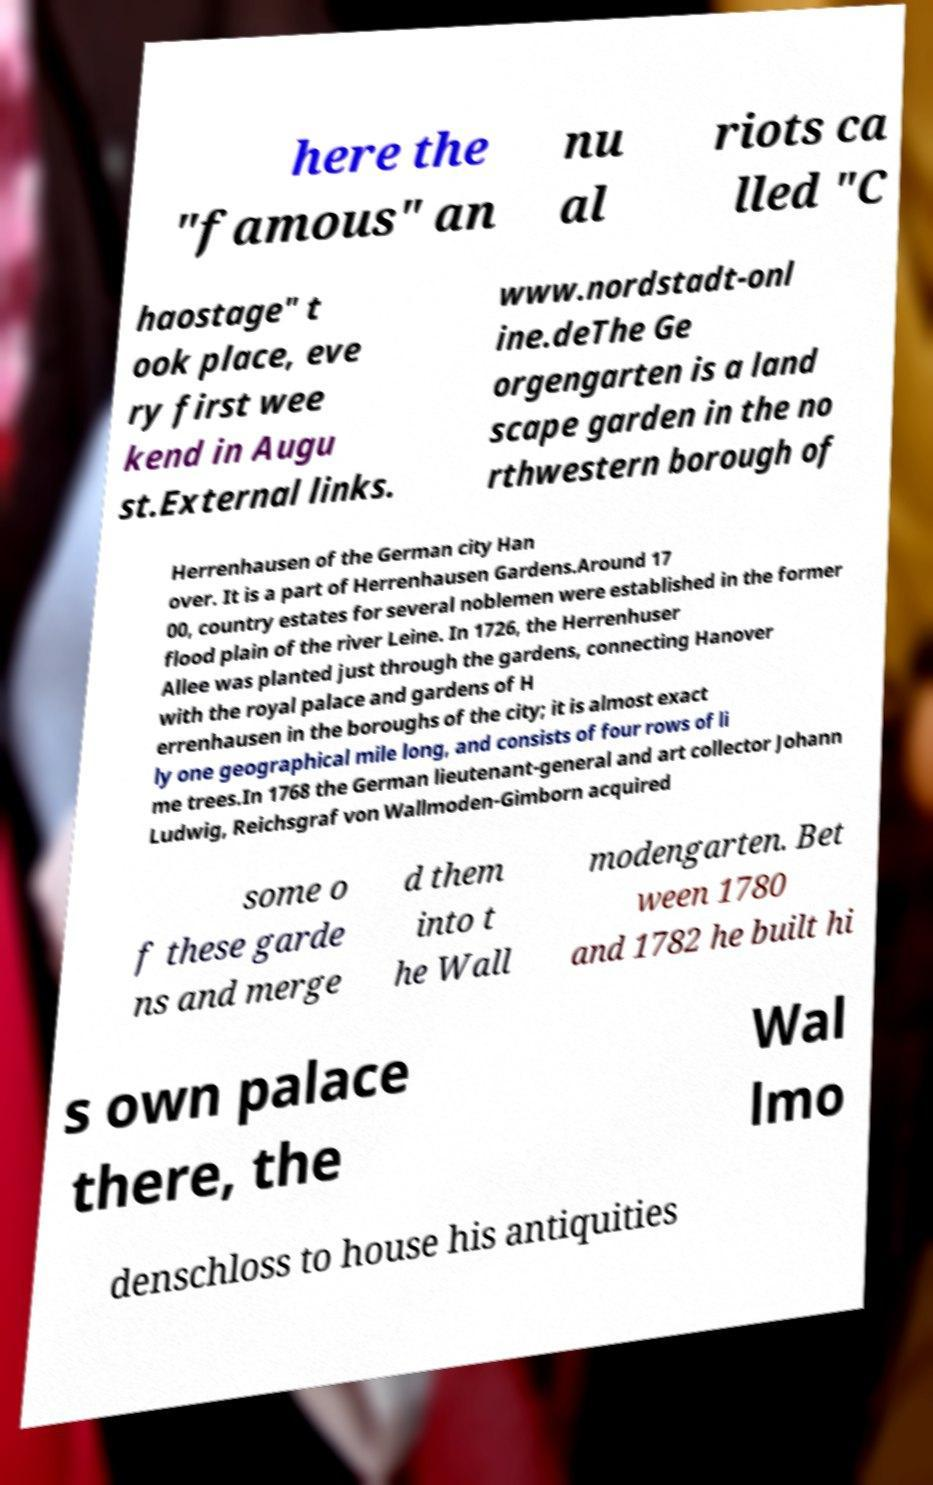Can you accurately transcribe the text from the provided image for me? here the "famous" an nu al riots ca lled "C haostage" t ook place, eve ry first wee kend in Augu st.External links. www.nordstadt-onl ine.deThe Ge orgengarten is a land scape garden in the no rthwestern borough of Herrenhausen of the German city Han over. It is a part of Herrenhausen Gardens.Around 17 00, country estates for several noblemen were established in the former flood plain of the river Leine. In 1726, the Herrenhuser Allee was planted just through the gardens, connecting Hanover with the royal palace and gardens of H errenhausen in the boroughs of the city; it is almost exact ly one geographical mile long, and consists of four rows of li me trees.In 1768 the German lieutenant-general and art collector Johann Ludwig, Reichsgraf von Wallmoden-Gimborn acquired some o f these garde ns and merge d them into t he Wall modengarten. Bet ween 1780 and 1782 he built hi s own palace there, the Wal lmo denschloss to house his antiquities 